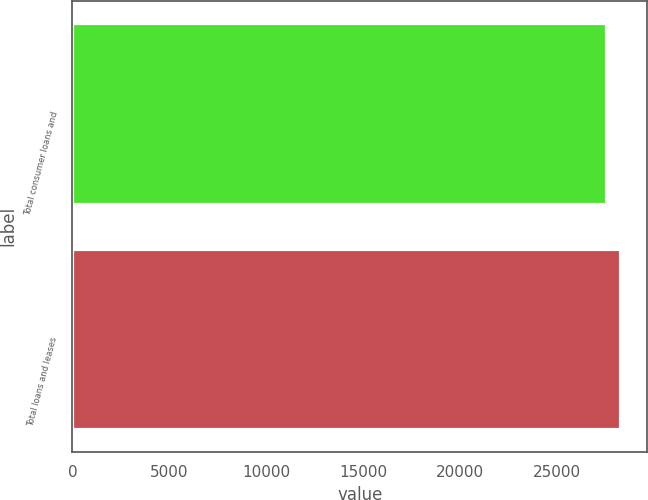<chart> <loc_0><loc_0><loc_500><loc_500><bar_chart><fcel>Total consumer loans and<fcel>Total loans and leases<nl><fcel>27533<fcel>28263<nl></chart> 